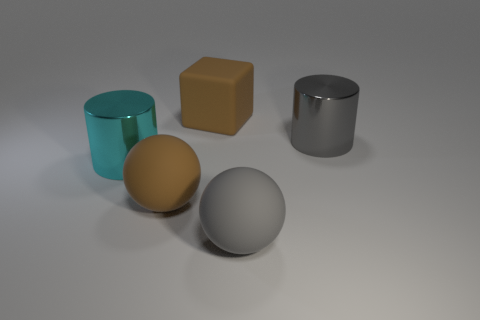Do the object that is to the left of the big brown matte sphere and the brown thing that is behind the large cyan metallic cylinder have the same size?
Offer a terse response. Yes. How many things are either cylinders to the right of the large brown cube or big yellow metallic spheres?
Offer a very short reply. 1. Are there fewer large cyan cylinders than big shiny things?
Keep it short and to the point. Yes. There is a rubber object that is on the left side of the big rubber thing behind the metallic thing right of the brown sphere; what is its shape?
Your response must be concise. Sphere. There is a big rubber thing that is the same color as the block; what shape is it?
Provide a short and direct response. Sphere. Are there any large metal cylinders?
Your answer should be very brief. Yes. Is the size of the cyan object the same as the gray metallic thing that is on the right side of the gray rubber ball?
Your answer should be very brief. Yes. There is a large gray rubber sphere that is in front of the big gray cylinder; is there a large gray metal object behind it?
Offer a terse response. Yes. What is the material of the large object that is on the right side of the big brown cube and behind the brown sphere?
Offer a terse response. Metal. There is a big cylinder that is behind the cyan thing left of the rubber object that is behind the brown matte sphere; what color is it?
Keep it short and to the point. Gray. 